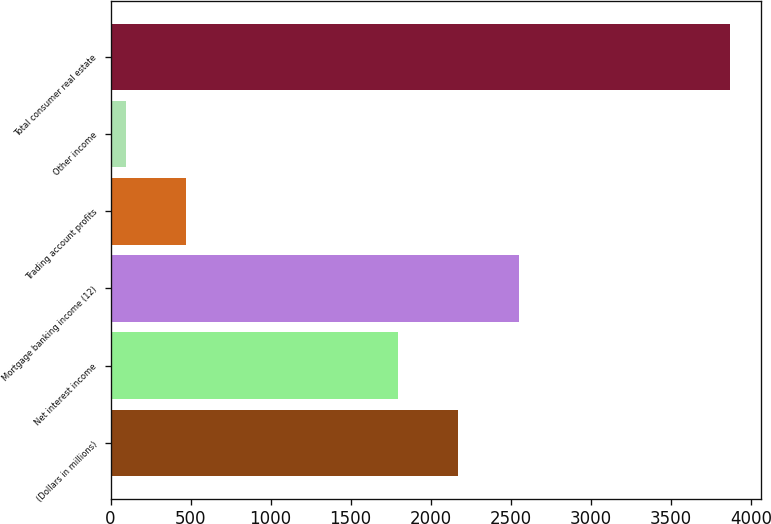Convert chart to OTSL. <chart><loc_0><loc_0><loc_500><loc_500><bar_chart><fcel>(Dollars in millions)<fcel>Net interest income<fcel>Mortgage banking income (12)<fcel>Trading account profits<fcel>Other income<fcel>Total consumer real estate<nl><fcel>2172.6<fcel>1795<fcel>2550.2<fcel>473.6<fcel>96<fcel>3872<nl></chart> 